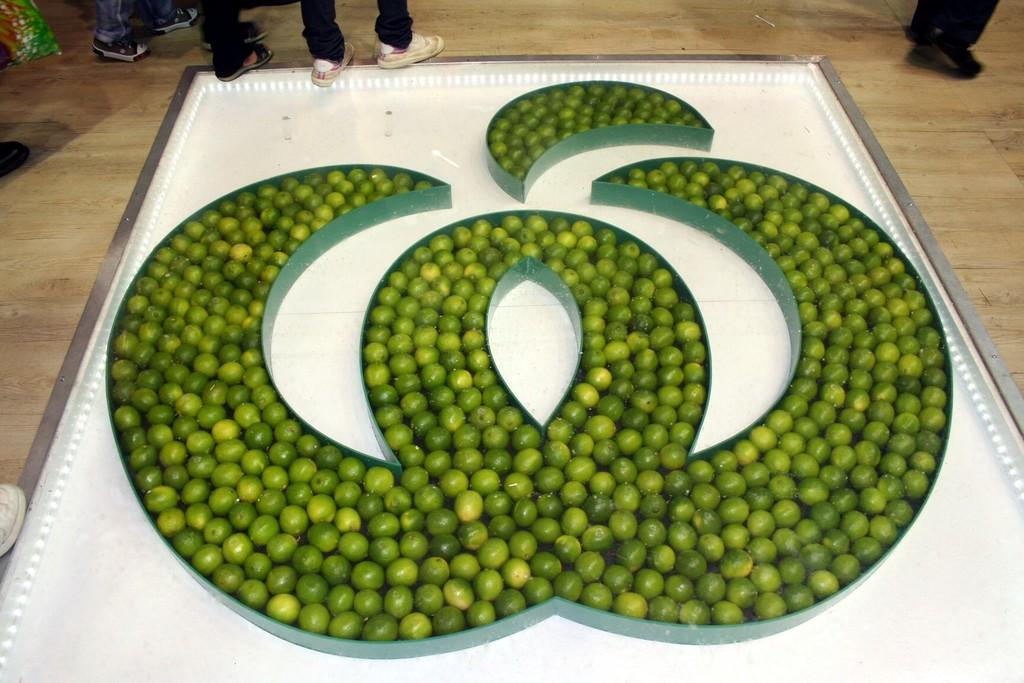What is arranged in a sequence manner in the image? There are fruits arranged in a sequence manner in the image. Where is the arrangement located? The arrangement is on the floor. Are there any people present in the image? Yes, there are people present in the image. What type of smile can be seen on the rice in the image? There is no rice present in the image, and therefore no smile can be seen on it. 